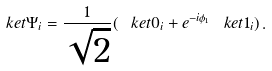Convert formula to latex. <formula><loc_0><loc_0><loc_500><loc_500>\ k e t { \Psi } _ { i } = \frac { 1 } { \sqrt { 2 } } ( \ k e t { 0 } _ { i } + e ^ { - i \phi _ { 1 } } \ k e t { 1 } _ { i } ) \, .</formula> 